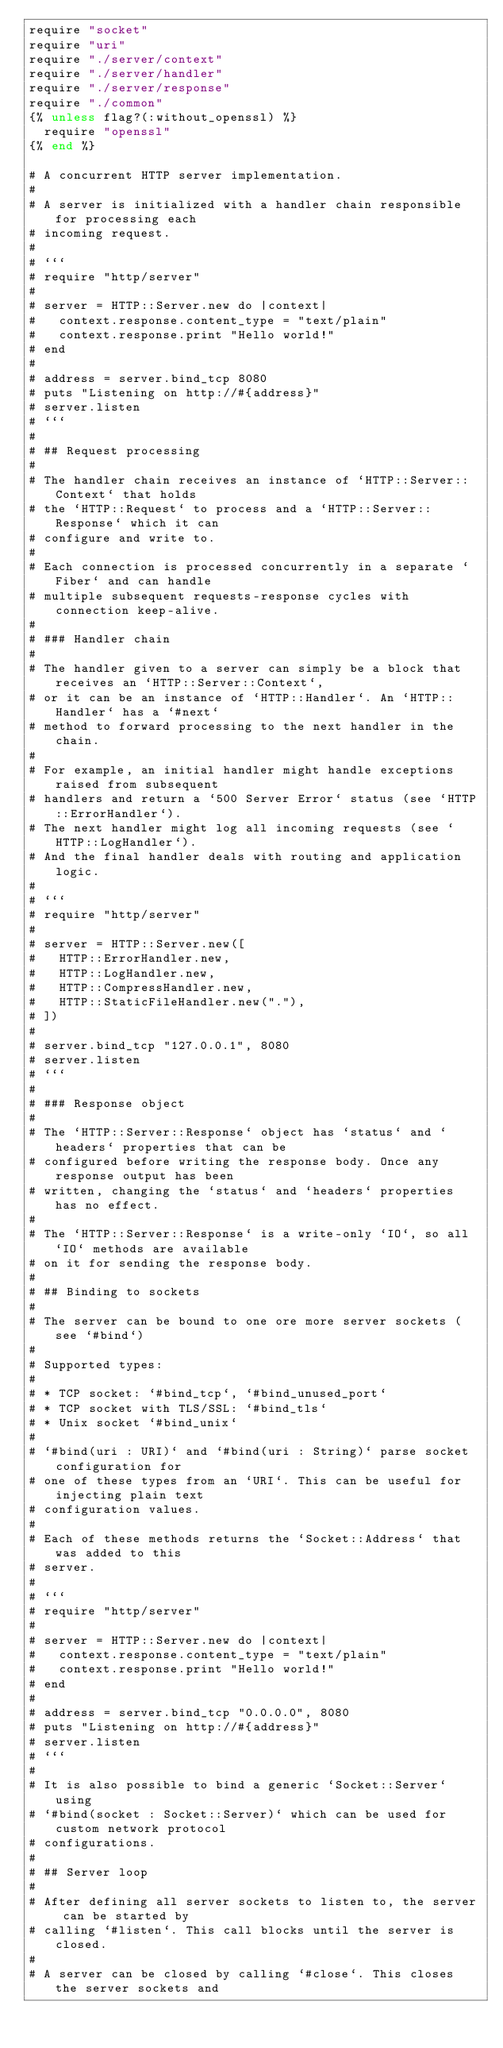Convert code to text. <code><loc_0><loc_0><loc_500><loc_500><_Crystal_>require "socket"
require "uri"
require "./server/context"
require "./server/handler"
require "./server/response"
require "./common"
{% unless flag?(:without_openssl) %}
  require "openssl"
{% end %}

# A concurrent HTTP server implementation.
#
# A server is initialized with a handler chain responsible for processing each
# incoming request.
#
# ```
# require "http/server"
#
# server = HTTP::Server.new do |context|
#   context.response.content_type = "text/plain"
#   context.response.print "Hello world!"
# end
#
# address = server.bind_tcp 8080
# puts "Listening on http://#{address}"
# server.listen
# ```
#
# ## Request processing
#
# The handler chain receives an instance of `HTTP::Server::Context` that holds
# the `HTTP::Request` to process and a `HTTP::Server::Response` which it can
# configure and write to.
#
# Each connection is processed concurrently in a separate `Fiber` and can handle
# multiple subsequent requests-response cycles with connection keep-alive.
#
# ### Handler chain
#
# The handler given to a server can simply be a block that receives an `HTTP::Server::Context`,
# or it can be an instance of `HTTP::Handler`. An `HTTP::Handler` has a `#next`
# method to forward processing to the next handler in the chain.
#
# For example, an initial handler might handle exceptions raised from subsequent
# handlers and return a `500 Server Error` status (see `HTTP::ErrorHandler`).
# The next handler might log all incoming requests (see `HTTP::LogHandler`).
# And the final handler deals with routing and application logic.
#
# ```
# require "http/server"
#
# server = HTTP::Server.new([
#   HTTP::ErrorHandler.new,
#   HTTP::LogHandler.new,
#   HTTP::CompressHandler.new,
#   HTTP::StaticFileHandler.new("."),
# ])
#
# server.bind_tcp "127.0.0.1", 8080
# server.listen
# ```
#
# ### Response object
#
# The `HTTP::Server::Response` object has `status` and `headers` properties that can be
# configured before writing the response body. Once any response output has been
# written, changing the `status` and `headers` properties has no effect.
#
# The `HTTP::Server::Response` is a write-only `IO`, so all `IO` methods are available
# on it for sending the response body.
#
# ## Binding to sockets
#
# The server can be bound to one ore more server sockets (see `#bind`)
#
# Supported types:
#
# * TCP socket: `#bind_tcp`, `#bind_unused_port`
# * TCP socket with TLS/SSL: `#bind_tls`
# * Unix socket `#bind_unix`
#
# `#bind(uri : URI)` and `#bind(uri : String)` parse socket configuration for
# one of these types from an `URI`. This can be useful for injecting plain text
# configuration values.
#
# Each of these methods returns the `Socket::Address` that was added to this
# server.
#
# ```
# require "http/server"
#
# server = HTTP::Server.new do |context|
#   context.response.content_type = "text/plain"
#   context.response.print "Hello world!"
# end
#
# address = server.bind_tcp "0.0.0.0", 8080
# puts "Listening on http://#{address}"
# server.listen
# ```
#
# It is also possible to bind a generic `Socket::Server` using
# `#bind(socket : Socket::Server)` which can be used for custom network protocol
# configurations.
#
# ## Server loop
#
# After defining all server sockets to listen to, the server can be started by
# calling `#listen`. This call blocks until the server is closed.
#
# A server can be closed by calling `#close`. This closes the server sockets and</code> 